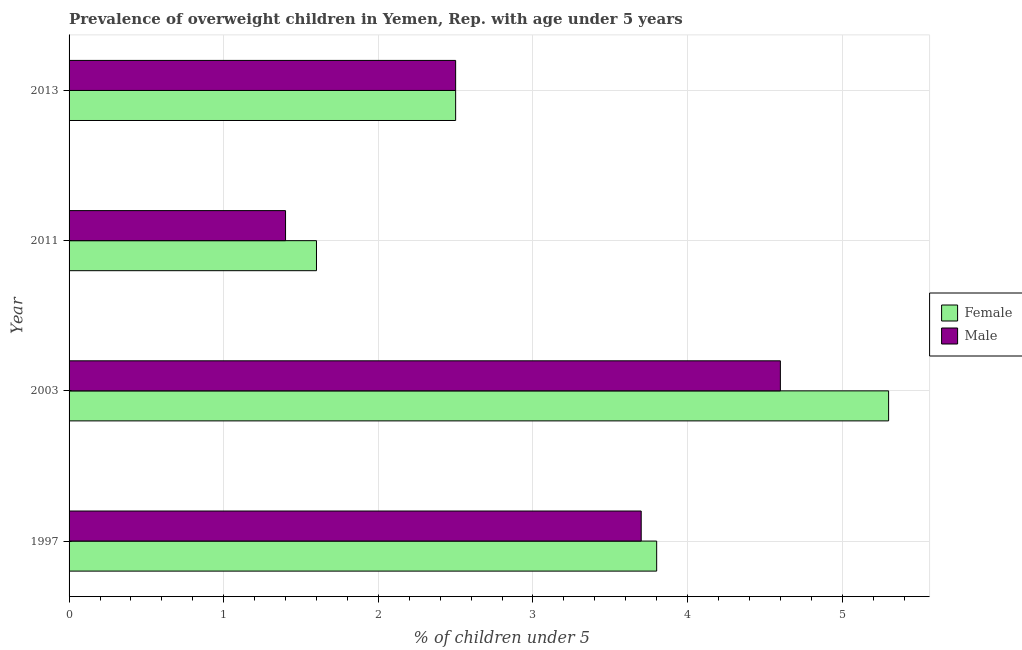How many different coloured bars are there?
Keep it short and to the point. 2. Are the number of bars per tick equal to the number of legend labels?
Provide a short and direct response. Yes. How many bars are there on the 2nd tick from the top?
Offer a terse response. 2. What is the label of the 3rd group of bars from the top?
Make the answer very short. 2003. What is the percentage of obese male children in 2003?
Keep it short and to the point. 4.6. Across all years, what is the maximum percentage of obese male children?
Provide a short and direct response. 4.6. Across all years, what is the minimum percentage of obese male children?
Your response must be concise. 1.4. In which year was the percentage of obese female children maximum?
Your answer should be very brief. 2003. In which year was the percentage of obese male children minimum?
Your answer should be compact. 2011. What is the total percentage of obese male children in the graph?
Ensure brevity in your answer.  12.2. What is the difference between the percentage of obese female children in 2003 and the percentage of obese male children in 2013?
Give a very brief answer. 2.8. What is the average percentage of obese male children per year?
Make the answer very short. 3.05. In how many years, is the percentage of obese male children greater than 1.8 %?
Provide a short and direct response. 3. What is the ratio of the percentage of obese female children in 2011 to that in 2013?
Ensure brevity in your answer.  0.64. Is the percentage of obese female children in 1997 less than that in 2011?
Your answer should be very brief. No. Is the difference between the percentage of obese female children in 1997 and 2013 greater than the difference between the percentage of obese male children in 1997 and 2013?
Keep it short and to the point. Yes. In how many years, is the percentage of obese female children greater than the average percentage of obese female children taken over all years?
Keep it short and to the point. 2. Are the values on the major ticks of X-axis written in scientific E-notation?
Keep it short and to the point. No. Does the graph contain any zero values?
Your answer should be very brief. No. What is the title of the graph?
Your answer should be very brief. Prevalence of overweight children in Yemen, Rep. with age under 5 years. Does "Long-term debt" appear as one of the legend labels in the graph?
Provide a succinct answer. No. What is the label or title of the X-axis?
Keep it short and to the point.  % of children under 5. What is the  % of children under 5 of Female in 1997?
Give a very brief answer. 3.8. What is the  % of children under 5 in Male in 1997?
Keep it short and to the point. 3.7. What is the  % of children under 5 in Female in 2003?
Provide a succinct answer. 5.3. What is the  % of children under 5 of Male in 2003?
Offer a very short reply. 4.6. What is the  % of children under 5 of Female in 2011?
Your answer should be compact. 1.6. What is the  % of children under 5 of Male in 2011?
Make the answer very short. 1.4. What is the  % of children under 5 in Female in 2013?
Give a very brief answer. 2.5. Across all years, what is the maximum  % of children under 5 in Female?
Provide a short and direct response. 5.3. Across all years, what is the maximum  % of children under 5 of Male?
Your answer should be compact. 4.6. Across all years, what is the minimum  % of children under 5 in Female?
Keep it short and to the point. 1.6. Across all years, what is the minimum  % of children under 5 in Male?
Ensure brevity in your answer.  1.4. What is the total  % of children under 5 of Female in the graph?
Offer a very short reply. 13.2. What is the difference between the  % of children under 5 of Female in 1997 and that in 2013?
Your answer should be very brief. 1.3. What is the difference between the  % of children under 5 of Male in 2003 and that in 2011?
Your answer should be compact. 3.2. What is the difference between the  % of children under 5 of Female in 2003 and that in 2013?
Provide a succinct answer. 2.8. What is the difference between the  % of children under 5 in Female in 2011 and that in 2013?
Keep it short and to the point. -0.9. What is the difference between the  % of children under 5 of Female in 1997 and the  % of children under 5 of Male in 2011?
Make the answer very short. 2.4. What is the difference between the  % of children under 5 of Female in 1997 and the  % of children under 5 of Male in 2013?
Your response must be concise. 1.3. What is the average  % of children under 5 of Female per year?
Provide a succinct answer. 3.3. What is the average  % of children under 5 of Male per year?
Your answer should be compact. 3.05. In the year 2003, what is the difference between the  % of children under 5 of Female and  % of children under 5 of Male?
Provide a short and direct response. 0.7. In the year 2013, what is the difference between the  % of children under 5 in Female and  % of children under 5 in Male?
Your response must be concise. 0. What is the ratio of the  % of children under 5 of Female in 1997 to that in 2003?
Your answer should be very brief. 0.72. What is the ratio of the  % of children under 5 in Male in 1997 to that in 2003?
Ensure brevity in your answer.  0.8. What is the ratio of the  % of children under 5 of Female in 1997 to that in 2011?
Offer a terse response. 2.38. What is the ratio of the  % of children under 5 of Male in 1997 to that in 2011?
Make the answer very short. 2.64. What is the ratio of the  % of children under 5 in Female in 1997 to that in 2013?
Your answer should be compact. 1.52. What is the ratio of the  % of children under 5 in Male in 1997 to that in 2013?
Your response must be concise. 1.48. What is the ratio of the  % of children under 5 in Female in 2003 to that in 2011?
Offer a very short reply. 3.31. What is the ratio of the  % of children under 5 of Male in 2003 to that in 2011?
Ensure brevity in your answer.  3.29. What is the ratio of the  % of children under 5 of Female in 2003 to that in 2013?
Provide a succinct answer. 2.12. What is the ratio of the  % of children under 5 of Male in 2003 to that in 2013?
Provide a short and direct response. 1.84. What is the ratio of the  % of children under 5 in Female in 2011 to that in 2013?
Provide a succinct answer. 0.64. What is the ratio of the  % of children under 5 of Male in 2011 to that in 2013?
Your answer should be compact. 0.56. What is the difference between the highest and the second highest  % of children under 5 in Female?
Your answer should be very brief. 1.5. What is the difference between the highest and the second highest  % of children under 5 of Male?
Provide a succinct answer. 0.9. What is the difference between the highest and the lowest  % of children under 5 of Female?
Your response must be concise. 3.7. 